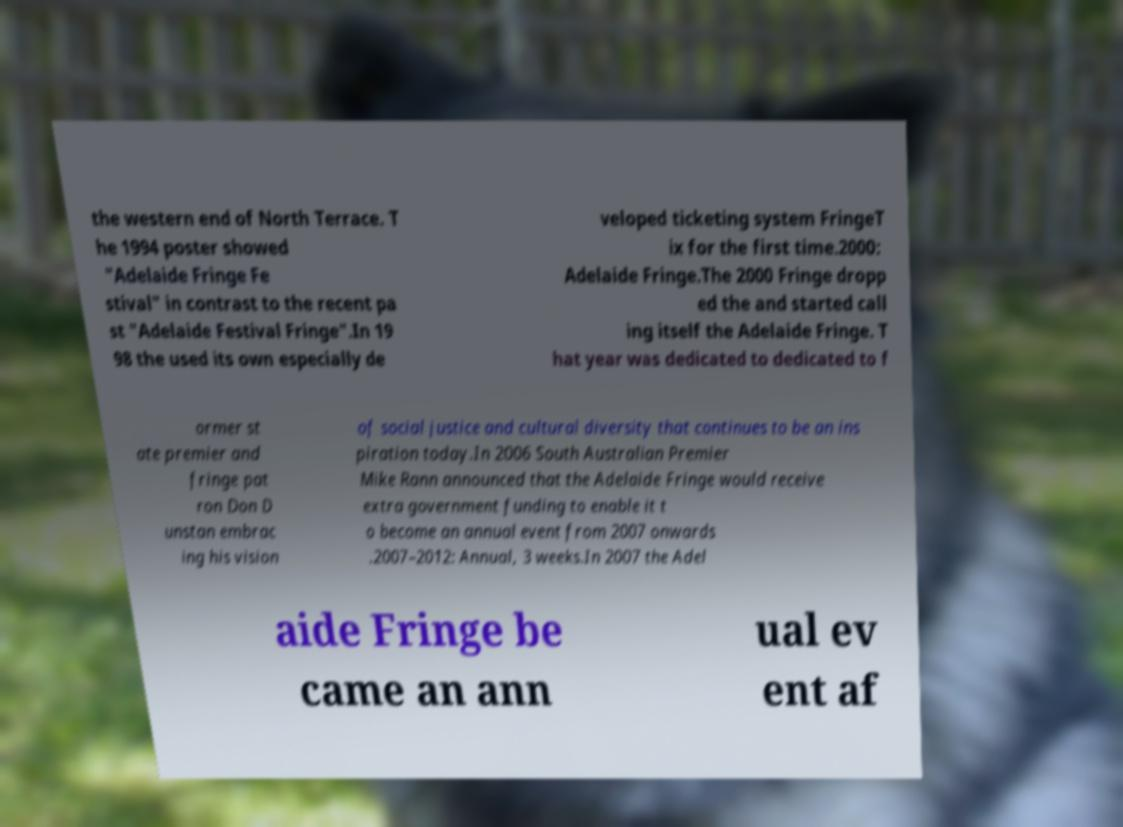Please identify and transcribe the text found in this image. the western end of North Terrace. T he 1994 poster showed "Adelaide Fringe Fe stival" in contrast to the recent pa st "Adelaide Festival Fringe".In 19 98 the used its own especially de veloped ticketing system FringeT ix for the first time.2000: Adelaide Fringe.The 2000 Fringe dropp ed the and started call ing itself the Adelaide Fringe. T hat year was dedicated to dedicated to f ormer st ate premier and fringe pat ron Don D unstan embrac ing his vision of social justice and cultural diversity that continues to be an ins piration today.In 2006 South Australian Premier Mike Rann announced that the Adelaide Fringe would receive extra government funding to enable it t o become an annual event from 2007 onwards .2007–2012: Annual, 3 weeks.In 2007 the Adel aide Fringe be came an ann ual ev ent af 